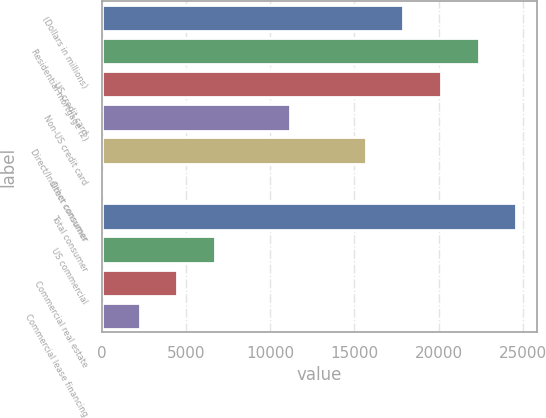Convert chart. <chart><loc_0><loc_0><loc_500><loc_500><bar_chart><fcel>(Dollars in millions)<fcel>Residential mortgage (2)<fcel>US credit card<fcel>Non-US credit card<fcel>Direct/Indirect consumer<fcel>Other consumer<fcel>Total consumer<fcel>US commercial<fcel>Commercial real estate<fcel>Commercial lease financing<nl><fcel>17903.6<fcel>22379<fcel>20141.3<fcel>11190.5<fcel>15665.9<fcel>2<fcel>24616.7<fcel>6715.1<fcel>4477.4<fcel>2239.7<nl></chart> 